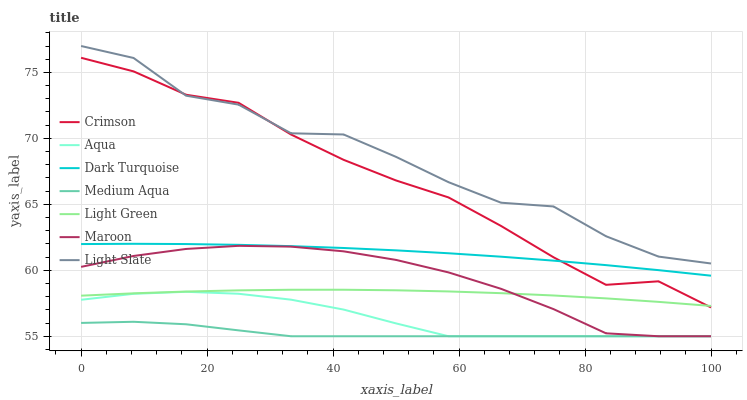Does Medium Aqua have the minimum area under the curve?
Answer yes or no. Yes. Does Light Slate have the maximum area under the curve?
Answer yes or no. Yes. Does Dark Turquoise have the minimum area under the curve?
Answer yes or no. No. Does Dark Turquoise have the maximum area under the curve?
Answer yes or no. No. Is Dark Turquoise the smoothest?
Answer yes or no. Yes. Is Light Slate the roughest?
Answer yes or no. Yes. Is Aqua the smoothest?
Answer yes or no. No. Is Aqua the roughest?
Answer yes or no. No. Does Dark Turquoise have the lowest value?
Answer yes or no. No. Does Light Slate have the highest value?
Answer yes or no. Yes. Does Dark Turquoise have the highest value?
Answer yes or no. No. Is Maroon less than Crimson?
Answer yes or no. Yes. Is Crimson greater than Maroon?
Answer yes or no. Yes. Does Maroon intersect Light Green?
Answer yes or no. Yes. Is Maroon less than Light Green?
Answer yes or no. No. Is Maroon greater than Light Green?
Answer yes or no. No. Does Maroon intersect Crimson?
Answer yes or no. No. 